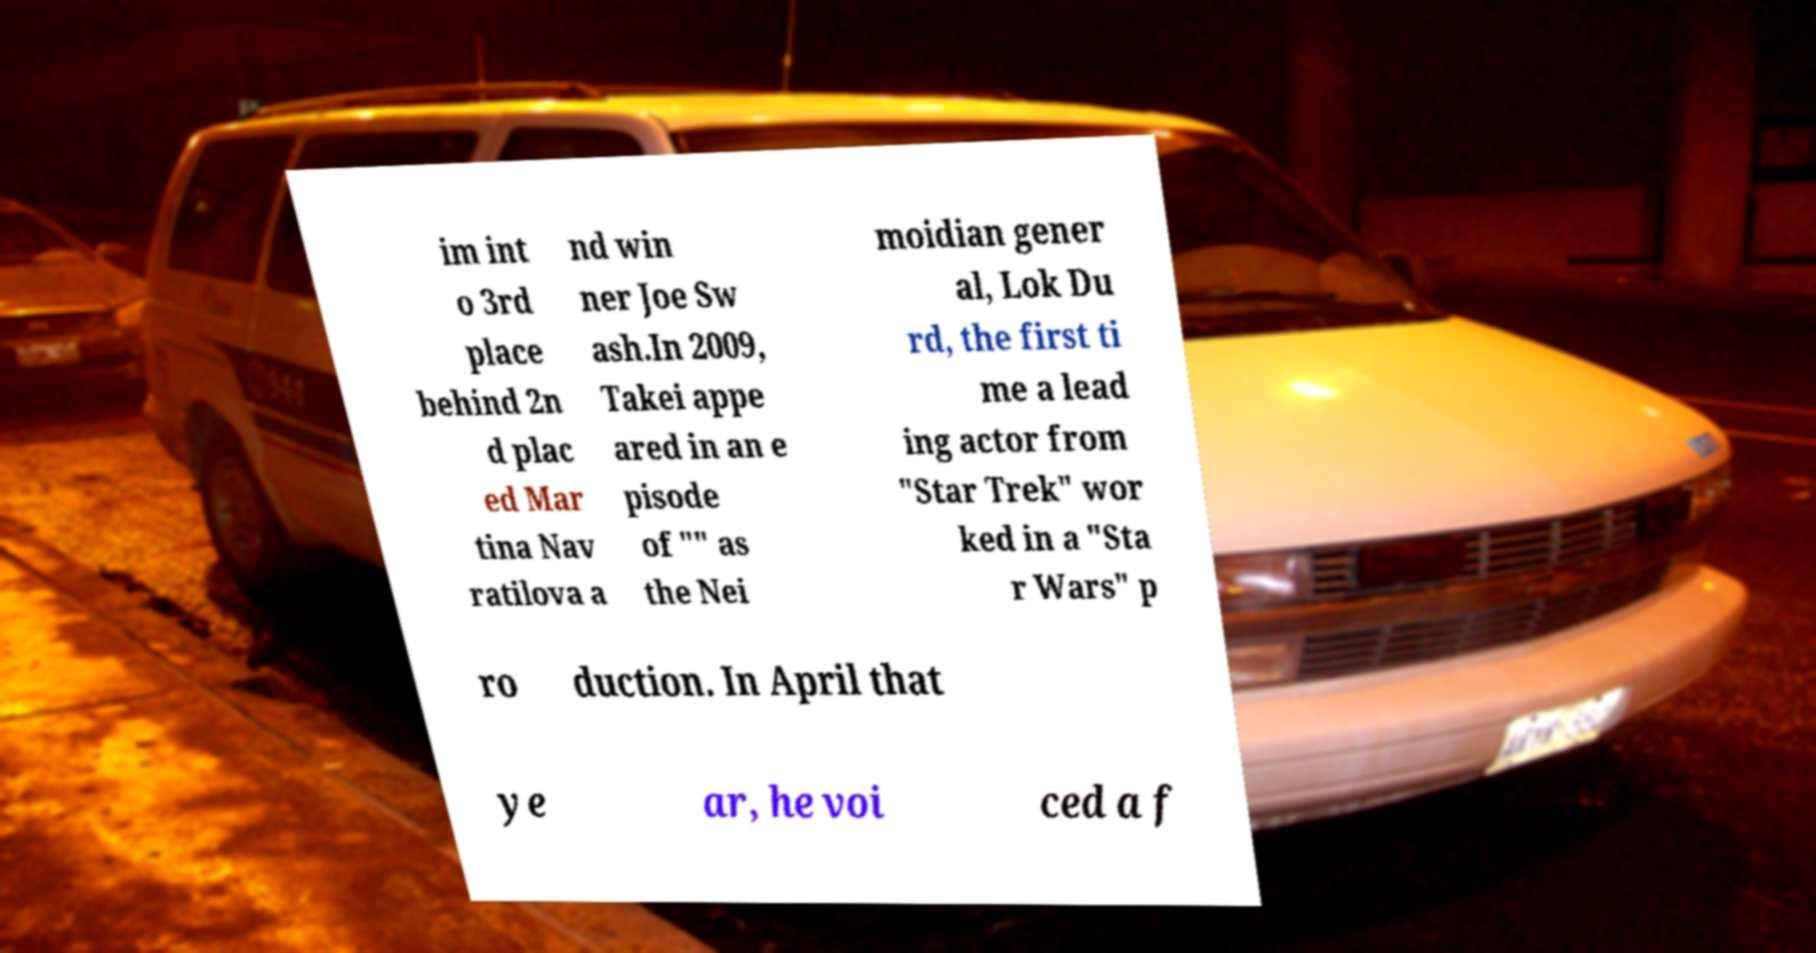Could you assist in decoding the text presented in this image and type it out clearly? im int o 3rd place behind 2n d plac ed Mar tina Nav ratilova a nd win ner Joe Sw ash.In 2009, Takei appe ared in an e pisode of "" as the Nei moidian gener al, Lok Du rd, the first ti me a lead ing actor from "Star Trek" wor ked in a "Sta r Wars" p ro duction. In April that ye ar, he voi ced a f 